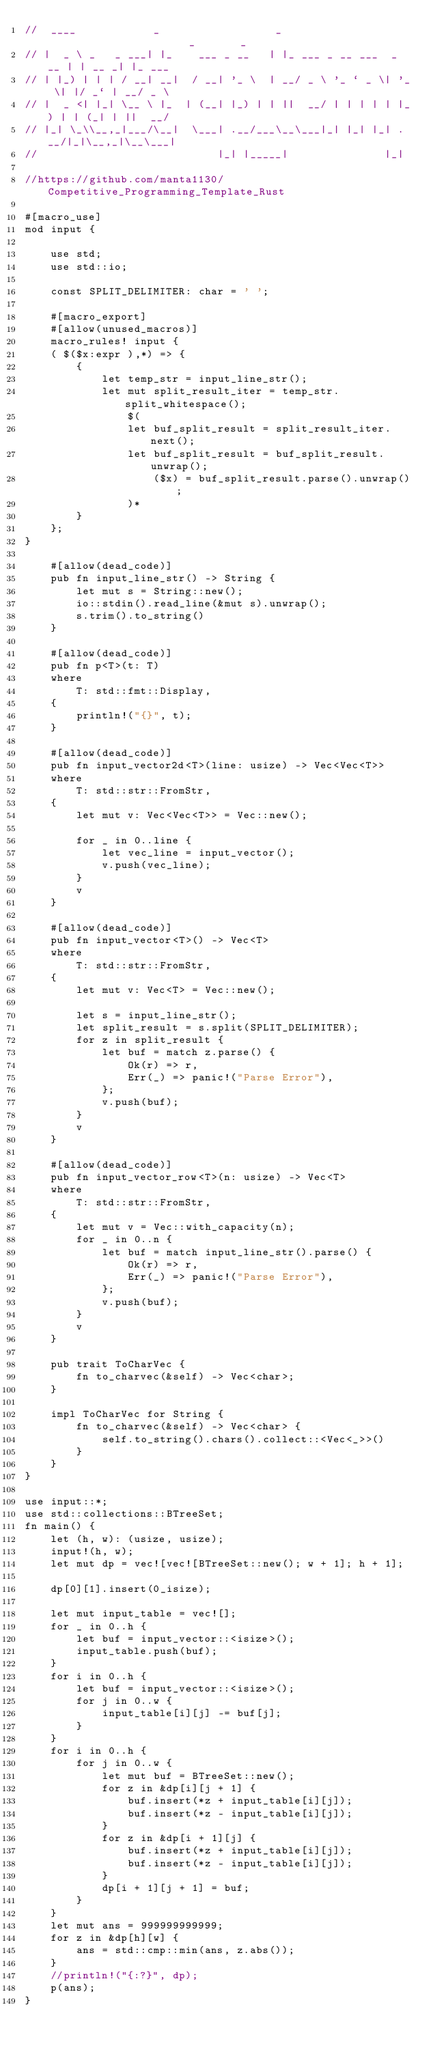Convert code to text. <code><loc_0><loc_0><loc_500><loc_500><_Rust_>//  ____            _                  _                       _       _
// |  _ \ _   _ ___| |_    ___ _ __   | |_ ___ _ __ ___  _ __ | | __ _| |_ ___
// | |_) | | | / __| __|  / __| '_ \  | __/ _ \ '_ ` _ \| '_ \| |/ _` | __/ _ \
// |  _ <| |_| \__ \ |_  | (__| |_) | | ||  __/ | | | | | |_) | | (_| | ||  __/
// |_| \_\\__,_|___/\__|  \___| .__/___\__\___|_| |_| |_| .__/|_|\__,_|\__\___|
//                            |_| |_____|               |_|

//https://github.com/manta1130/Competitive_Programming_Template_Rust

#[macro_use]
mod input {

    use std;
    use std::io;

    const SPLIT_DELIMITER: char = ' ';

    #[macro_export]
    #[allow(unused_macros)]
    macro_rules! input {
    ( $($x:expr ),*) => {
        {
            let temp_str = input_line_str();
            let mut split_result_iter = temp_str.split_whitespace();
                $(
                let buf_split_result = split_result_iter.next();
                let buf_split_result = buf_split_result.unwrap();
                    ($x) = buf_split_result.parse().unwrap();
                )*
        }
    };
}

    #[allow(dead_code)]
    pub fn input_line_str() -> String {
        let mut s = String::new();
        io::stdin().read_line(&mut s).unwrap();
        s.trim().to_string()
    }

    #[allow(dead_code)]
    pub fn p<T>(t: T)
    where
        T: std::fmt::Display,
    {
        println!("{}", t);
    }

    #[allow(dead_code)]
    pub fn input_vector2d<T>(line: usize) -> Vec<Vec<T>>
    where
        T: std::str::FromStr,
    {
        let mut v: Vec<Vec<T>> = Vec::new();

        for _ in 0..line {
            let vec_line = input_vector();
            v.push(vec_line);
        }
        v
    }

    #[allow(dead_code)]
    pub fn input_vector<T>() -> Vec<T>
    where
        T: std::str::FromStr,
    {
        let mut v: Vec<T> = Vec::new();

        let s = input_line_str();
        let split_result = s.split(SPLIT_DELIMITER);
        for z in split_result {
            let buf = match z.parse() {
                Ok(r) => r,
                Err(_) => panic!("Parse Error"),
            };
            v.push(buf);
        }
        v
    }

    #[allow(dead_code)]
    pub fn input_vector_row<T>(n: usize) -> Vec<T>
    where
        T: std::str::FromStr,
    {
        let mut v = Vec::with_capacity(n);
        for _ in 0..n {
            let buf = match input_line_str().parse() {
                Ok(r) => r,
                Err(_) => panic!("Parse Error"),
            };
            v.push(buf);
        }
        v
    }

    pub trait ToCharVec {
        fn to_charvec(&self) -> Vec<char>;
    }

    impl ToCharVec for String {
        fn to_charvec(&self) -> Vec<char> {
            self.to_string().chars().collect::<Vec<_>>()
        }
    }
}

use input::*;
use std::collections::BTreeSet;
fn main() {
    let (h, w): (usize, usize);
    input!(h, w);
    let mut dp = vec![vec![BTreeSet::new(); w + 1]; h + 1];

    dp[0][1].insert(0_isize);

    let mut input_table = vec![];
    for _ in 0..h {
        let buf = input_vector::<isize>();
        input_table.push(buf);
    }
    for i in 0..h {
        let buf = input_vector::<isize>();
        for j in 0..w {
            input_table[i][j] -= buf[j];
        }
    }
    for i in 0..h {
        for j in 0..w {
            let mut buf = BTreeSet::new();
            for z in &dp[i][j + 1] {
                buf.insert(*z + input_table[i][j]);
                buf.insert(*z - input_table[i][j]);
            }
            for z in &dp[i + 1][j] {
                buf.insert(*z + input_table[i][j]);
                buf.insert(*z - input_table[i][j]);
            }
            dp[i + 1][j + 1] = buf;
        }
    }
    let mut ans = 999999999999;
    for z in &dp[h][w] {
        ans = std::cmp::min(ans, z.abs());
    }
    //println!("{:?}", dp);
    p(ans);
}
</code> 